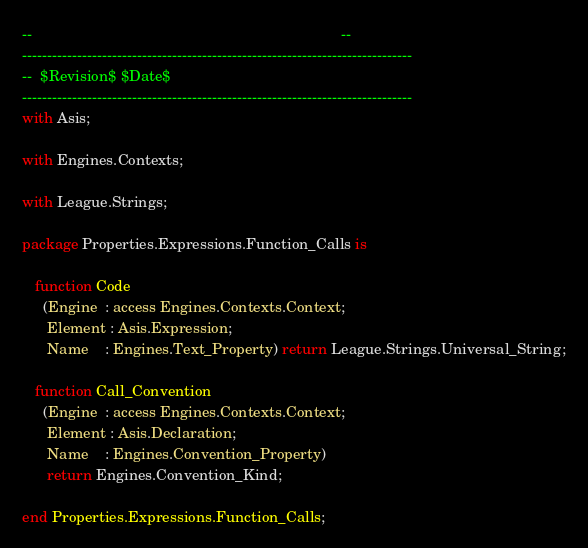Convert code to text. <code><loc_0><loc_0><loc_500><loc_500><_Ada_>--                                                                          --
------------------------------------------------------------------------------
--  $Revision$ $Date$
------------------------------------------------------------------------------
with Asis;

with Engines.Contexts;

with League.Strings;

package Properties.Expressions.Function_Calls is

   function Code
     (Engine  : access Engines.Contexts.Context;
      Element : Asis.Expression;
      Name    : Engines.Text_Property) return League.Strings.Universal_String;

   function Call_Convention
     (Engine  : access Engines.Contexts.Context;
      Element : Asis.Declaration;
      Name    : Engines.Convention_Property)
      return Engines.Convention_Kind;

end Properties.Expressions.Function_Calls;
</code> 